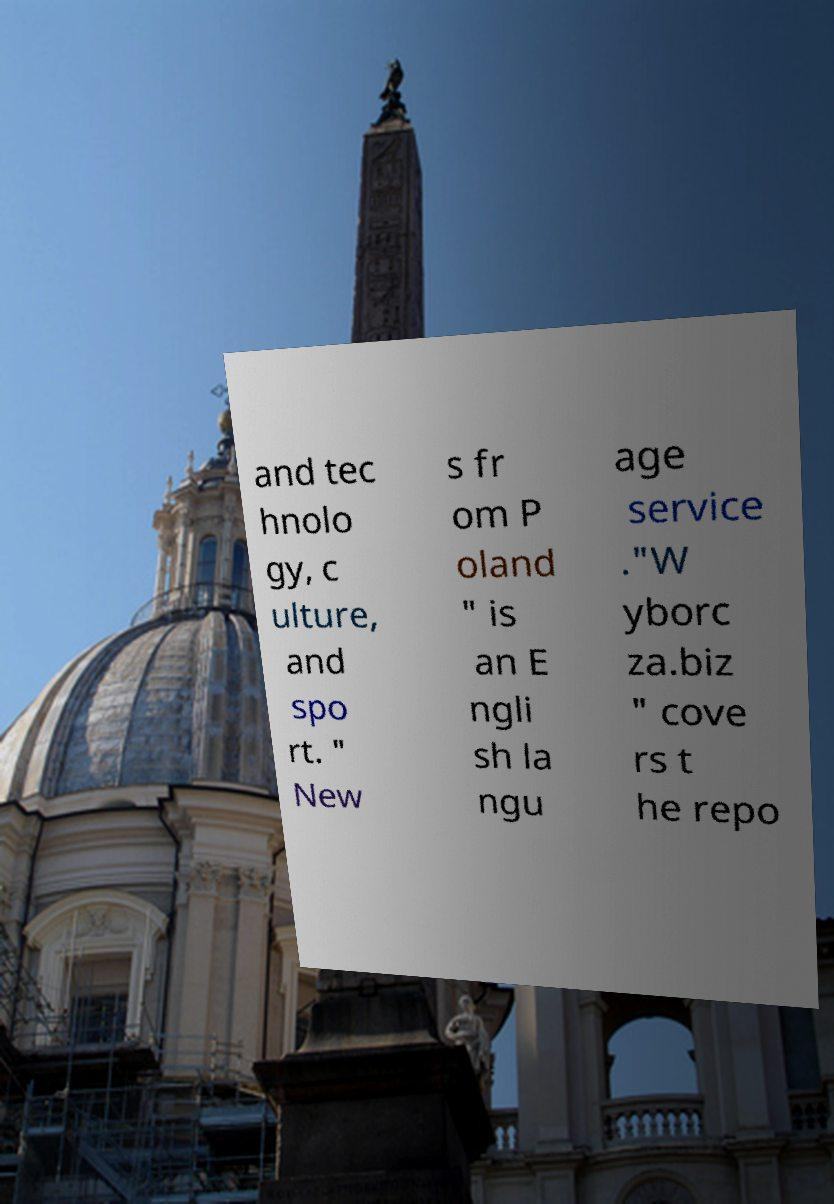There's text embedded in this image that I need extracted. Can you transcribe it verbatim? and tec hnolo gy, c ulture, and spo rt. " New s fr om P oland " is an E ngli sh la ngu age service ."W yborc za.biz " cove rs t he repo 